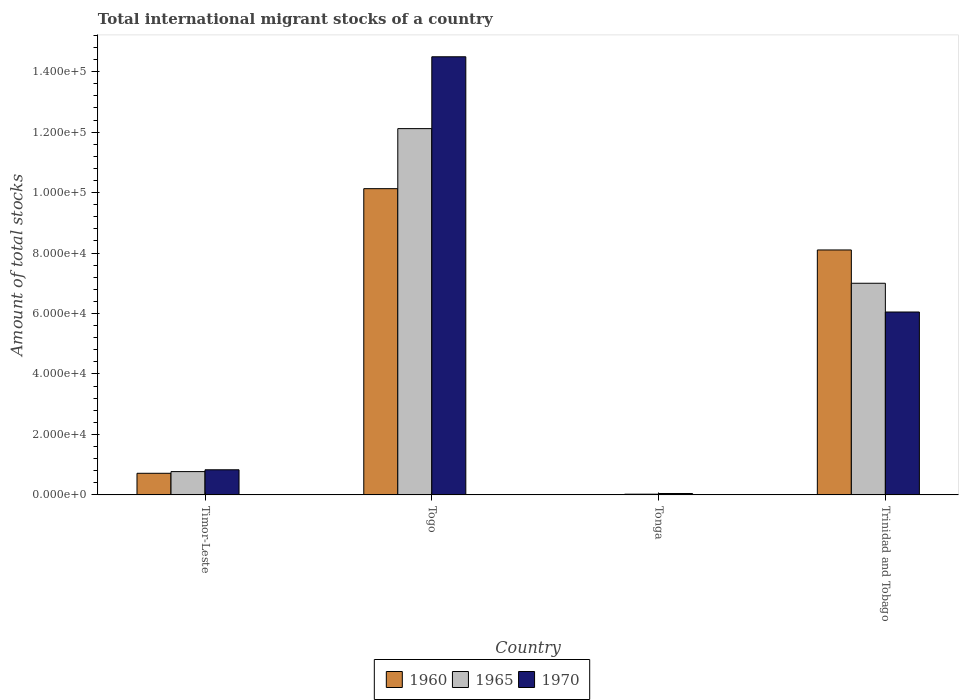How many groups of bars are there?
Provide a succinct answer. 4. How many bars are there on the 3rd tick from the right?
Give a very brief answer. 3. What is the label of the 1st group of bars from the left?
Give a very brief answer. Timor-Leste. In how many cases, is the number of bars for a given country not equal to the number of legend labels?
Provide a short and direct response. 0. What is the amount of total stocks in in 1960 in Timor-Leste?
Offer a very short reply. 7148. Across all countries, what is the maximum amount of total stocks in in 1960?
Offer a very short reply. 1.01e+05. Across all countries, what is the minimum amount of total stocks in in 1965?
Your answer should be very brief. 236. In which country was the amount of total stocks in in 1965 maximum?
Offer a terse response. Togo. In which country was the amount of total stocks in in 1970 minimum?
Keep it short and to the point. Tonga. What is the total amount of total stocks in in 1970 in the graph?
Offer a terse response. 2.14e+05. What is the difference between the amount of total stocks in in 1960 in Timor-Leste and that in Trinidad and Tobago?
Offer a terse response. -7.39e+04. What is the difference between the amount of total stocks in in 1960 in Trinidad and Tobago and the amount of total stocks in in 1970 in Timor-Leste?
Your answer should be compact. 7.27e+04. What is the average amount of total stocks in in 1965 per country?
Ensure brevity in your answer.  4.98e+04. What is the difference between the amount of total stocks in of/in 1960 and amount of total stocks in of/in 1970 in Timor-Leste?
Ensure brevity in your answer.  -1158. In how many countries, is the amount of total stocks in in 1960 greater than 72000?
Make the answer very short. 2. What is the ratio of the amount of total stocks in in 1965 in Togo to that in Trinidad and Tobago?
Provide a succinct answer. 1.73. Is the amount of total stocks in in 1965 in Togo less than that in Trinidad and Tobago?
Offer a very short reply. No. Is the difference between the amount of total stocks in in 1960 in Togo and Trinidad and Tobago greater than the difference between the amount of total stocks in in 1970 in Togo and Trinidad and Tobago?
Offer a very short reply. No. What is the difference between the highest and the second highest amount of total stocks in in 1970?
Give a very brief answer. -1.37e+05. What is the difference between the highest and the lowest amount of total stocks in in 1970?
Offer a very short reply. 1.44e+05. What does the 1st bar from the left in Tonga represents?
Your answer should be very brief. 1960. What does the 2nd bar from the right in Trinidad and Tobago represents?
Your answer should be very brief. 1965. Is it the case that in every country, the sum of the amount of total stocks in in 1970 and amount of total stocks in in 1960 is greater than the amount of total stocks in in 1965?
Your response must be concise. Yes. What is the difference between two consecutive major ticks on the Y-axis?
Give a very brief answer. 2.00e+04. Does the graph contain any zero values?
Offer a very short reply. No. How many legend labels are there?
Provide a succinct answer. 3. What is the title of the graph?
Provide a short and direct response. Total international migrant stocks of a country. Does "2013" appear as one of the legend labels in the graph?
Ensure brevity in your answer.  No. What is the label or title of the X-axis?
Provide a succinct answer. Country. What is the label or title of the Y-axis?
Ensure brevity in your answer.  Amount of total stocks. What is the Amount of total stocks in 1960 in Timor-Leste?
Your response must be concise. 7148. What is the Amount of total stocks of 1965 in Timor-Leste?
Provide a short and direct response. 7705. What is the Amount of total stocks of 1970 in Timor-Leste?
Offer a terse response. 8306. What is the Amount of total stocks in 1960 in Togo?
Your answer should be very brief. 1.01e+05. What is the Amount of total stocks in 1965 in Togo?
Your answer should be compact. 1.21e+05. What is the Amount of total stocks of 1970 in Togo?
Offer a terse response. 1.45e+05. What is the Amount of total stocks in 1960 in Tonga?
Keep it short and to the point. 121. What is the Amount of total stocks of 1965 in Tonga?
Provide a succinct answer. 236. What is the Amount of total stocks in 1970 in Tonga?
Your answer should be very brief. 460. What is the Amount of total stocks of 1960 in Trinidad and Tobago?
Give a very brief answer. 8.10e+04. What is the Amount of total stocks in 1965 in Trinidad and Tobago?
Make the answer very short. 7.00e+04. What is the Amount of total stocks in 1970 in Trinidad and Tobago?
Offer a very short reply. 6.05e+04. Across all countries, what is the maximum Amount of total stocks in 1960?
Keep it short and to the point. 1.01e+05. Across all countries, what is the maximum Amount of total stocks of 1965?
Your response must be concise. 1.21e+05. Across all countries, what is the maximum Amount of total stocks of 1970?
Provide a succinct answer. 1.45e+05. Across all countries, what is the minimum Amount of total stocks in 1960?
Make the answer very short. 121. Across all countries, what is the minimum Amount of total stocks of 1965?
Keep it short and to the point. 236. Across all countries, what is the minimum Amount of total stocks in 1970?
Make the answer very short. 460. What is the total Amount of total stocks in 1960 in the graph?
Keep it short and to the point. 1.90e+05. What is the total Amount of total stocks in 1965 in the graph?
Your response must be concise. 1.99e+05. What is the total Amount of total stocks of 1970 in the graph?
Your answer should be compact. 2.14e+05. What is the difference between the Amount of total stocks of 1960 in Timor-Leste and that in Togo?
Your answer should be very brief. -9.41e+04. What is the difference between the Amount of total stocks in 1965 in Timor-Leste and that in Togo?
Provide a succinct answer. -1.13e+05. What is the difference between the Amount of total stocks in 1970 in Timor-Leste and that in Togo?
Keep it short and to the point. -1.37e+05. What is the difference between the Amount of total stocks of 1960 in Timor-Leste and that in Tonga?
Offer a terse response. 7027. What is the difference between the Amount of total stocks in 1965 in Timor-Leste and that in Tonga?
Make the answer very short. 7469. What is the difference between the Amount of total stocks in 1970 in Timor-Leste and that in Tonga?
Your answer should be compact. 7846. What is the difference between the Amount of total stocks in 1960 in Timor-Leste and that in Trinidad and Tobago?
Your answer should be very brief. -7.39e+04. What is the difference between the Amount of total stocks of 1965 in Timor-Leste and that in Trinidad and Tobago?
Ensure brevity in your answer.  -6.23e+04. What is the difference between the Amount of total stocks in 1970 in Timor-Leste and that in Trinidad and Tobago?
Ensure brevity in your answer.  -5.22e+04. What is the difference between the Amount of total stocks in 1960 in Togo and that in Tonga?
Provide a short and direct response. 1.01e+05. What is the difference between the Amount of total stocks of 1965 in Togo and that in Tonga?
Your answer should be very brief. 1.21e+05. What is the difference between the Amount of total stocks in 1970 in Togo and that in Tonga?
Make the answer very short. 1.44e+05. What is the difference between the Amount of total stocks in 1960 in Togo and that in Trinidad and Tobago?
Provide a short and direct response. 2.03e+04. What is the difference between the Amount of total stocks of 1965 in Togo and that in Trinidad and Tobago?
Ensure brevity in your answer.  5.12e+04. What is the difference between the Amount of total stocks in 1970 in Togo and that in Trinidad and Tobago?
Ensure brevity in your answer.  8.44e+04. What is the difference between the Amount of total stocks in 1960 in Tonga and that in Trinidad and Tobago?
Give a very brief answer. -8.09e+04. What is the difference between the Amount of total stocks in 1965 in Tonga and that in Trinidad and Tobago?
Your response must be concise. -6.98e+04. What is the difference between the Amount of total stocks of 1970 in Tonga and that in Trinidad and Tobago?
Your response must be concise. -6.00e+04. What is the difference between the Amount of total stocks of 1960 in Timor-Leste and the Amount of total stocks of 1965 in Togo?
Your answer should be compact. -1.14e+05. What is the difference between the Amount of total stocks of 1960 in Timor-Leste and the Amount of total stocks of 1970 in Togo?
Make the answer very short. -1.38e+05. What is the difference between the Amount of total stocks of 1965 in Timor-Leste and the Amount of total stocks of 1970 in Togo?
Give a very brief answer. -1.37e+05. What is the difference between the Amount of total stocks of 1960 in Timor-Leste and the Amount of total stocks of 1965 in Tonga?
Provide a short and direct response. 6912. What is the difference between the Amount of total stocks in 1960 in Timor-Leste and the Amount of total stocks in 1970 in Tonga?
Your response must be concise. 6688. What is the difference between the Amount of total stocks of 1965 in Timor-Leste and the Amount of total stocks of 1970 in Tonga?
Give a very brief answer. 7245. What is the difference between the Amount of total stocks in 1960 in Timor-Leste and the Amount of total stocks in 1965 in Trinidad and Tobago?
Provide a short and direct response. -6.29e+04. What is the difference between the Amount of total stocks of 1960 in Timor-Leste and the Amount of total stocks of 1970 in Trinidad and Tobago?
Offer a terse response. -5.33e+04. What is the difference between the Amount of total stocks in 1965 in Timor-Leste and the Amount of total stocks in 1970 in Trinidad and Tobago?
Make the answer very short. -5.28e+04. What is the difference between the Amount of total stocks in 1960 in Togo and the Amount of total stocks in 1965 in Tonga?
Ensure brevity in your answer.  1.01e+05. What is the difference between the Amount of total stocks in 1960 in Togo and the Amount of total stocks in 1970 in Tonga?
Your response must be concise. 1.01e+05. What is the difference between the Amount of total stocks in 1965 in Togo and the Amount of total stocks in 1970 in Tonga?
Provide a succinct answer. 1.21e+05. What is the difference between the Amount of total stocks of 1960 in Togo and the Amount of total stocks of 1965 in Trinidad and Tobago?
Provide a short and direct response. 3.13e+04. What is the difference between the Amount of total stocks in 1960 in Togo and the Amount of total stocks in 1970 in Trinidad and Tobago?
Provide a short and direct response. 4.08e+04. What is the difference between the Amount of total stocks in 1965 in Togo and the Amount of total stocks in 1970 in Trinidad and Tobago?
Make the answer very short. 6.07e+04. What is the difference between the Amount of total stocks in 1960 in Tonga and the Amount of total stocks in 1965 in Trinidad and Tobago?
Your answer should be very brief. -6.99e+04. What is the difference between the Amount of total stocks in 1960 in Tonga and the Amount of total stocks in 1970 in Trinidad and Tobago?
Provide a short and direct response. -6.04e+04. What is the difference between the Amount of total stocks in 1965 in Tonga and the Amount of total stocks in 1970 in Trinidad and Tobago?
Provide a short and direct response. -6.03e+04. What is the average Amount of total stocks in 1960 per country?
Provide a short and direct response. 4.74e+04. What is the average Amount of total stocks of 1965 per country?
Your response must be concise. 4.98e+04. What is the average Amount of total stocks in 1970 per country?
Ensure brevity in your answer.  5.35e+04. What is the difference between the Amount of total stocks in 1960 and Amount of total stocks in 1965 in Timor-Leste?
Offer a terse response. -557. What is the difference between the Amount of total stocks in 1960 and Amount of total stocks in 1970 in Timor-Leste?
Offer a terse response. -1158. What is the difference between the Amount of total stocks of 1965 and Amount of total stocks of 1970 in Timor-Leste?
Keep it short and to the point. -601. What is the difference between the Amount of total stocks of 1960 and Amount of total stocks of 1965 in Togo?
Provide a succinct answer. -1.99e+04. What is the difference between the Amount of total stocks in 1960 and Amount of total stocks in 1970 in Togo?
Offer a very short reply. -4.36e+04. What is the difference between the Amount of total stocks in 1965 and Amount of total stocks in 1970 in Togo?
Give a very brief answer. -2.38e+04. What is the difference between the Amount of total stocks in 1960 and Amount of total stocks in 1965 in Tonga?
Offer a terse response. -115. What is the difference between the Amount of total stocks in 1960 and Amount of total stocks in 1970 in Tonga?
Your answer should be compact. -339. What is the difference between the Amount of total stocks of 1965 and Amount of total stocks of 1970 in Tonga?
Your answer should be compact. -224. What is the difference between the Amount of total stocks in 1960 and Amount of total stocks in 1965 in Trinidad and Tobago?
Offer a very short reply. 1.10e+04. What is the difference between the Amount of total stocks of 1960 and Amount of total stocks of 1970 in Trinidad and Tobago?
Keep it short and to the point. 2.05e+04. What is the difference between the Amount of total stocks of 1965 and Amount of total stocks of 1970 in Trinidad and Tobago?
Your response must be concise. 9509. What is the ratio of the Amount of total stocks in 1960 in Timor-Leste to that in Togo?
Your answer should be compact. 0.07. What is the ratio of the Amount of total stocks in 1965 in Timor-Leste to that in Togo?
Provide a succinct answer. 0.06. What is the ratio of the Amount of total stocks of 1970 in Timor-Leste to that in Togo?
Your answer should be very brief. 0.06. What is the ratio of the Amount of total stocks of 1960 in Timor-Leste to that in Tonga?
Your response must be concise. 59.07. What is the ratio of the Amount of total stocks in 1965 in Timor-Leste to that in Tonga?
Make the answer very short. 32.65. What is the ratio of the Amount of total stocks in 1970 in Timor-Leste to that in Tonga?
Keep it short and to the point. 18.06. What is the ratio of the Amount of total stocks in 1960 in Timor-Leste to that in Trinidad and Tobago?
Your answer should be compact. 0.09. What is the ratio of the Amount of total stocks of 1965 in Timor-Leste to that in Trinidad and Tobago?
Your answer should be very brief. 0.11. What is the ratio of the Amount of total stocks of 1970 in Timor-Leste to that in Trinidad and Tobago?
Make the answer very short. 0.14. What is the ratio of the Amount of total stocks of 1960 in Togo to that in Tonga?
Make the answer very short. 837.12. What is the ratio of the Amount of total stocks of 1965 in Togo to that in Tonga?
Your answer should be compact. 513.37. What is the ratio of the Amount of total stocks in 1970 in Togo to that in Tonga?
Offer a terse response. 315.03. What is the ratio of the Amount of total stocks in 1960 in Togo to that in Trinidad and Tobago?
Make the answer very short. 1.25. What is the ratio of the Amount of total stocks of 1965 in Togo to that in Trinidad and Tobago?
Your response must be concise. 1.73. What is the ratio of the Amount of total stocks of 1970 in Togo to that in Trinidad and Tobago?
Your answer should be very brief. 2.4. What is the ratio of the Amount of total stocks of 1960 in Tonga to that in Trinidad and Tobago?
Make the answer very short. 0. What is the ratio of the Amount of total stocks in 1965 in Tonga to that in Trinidad and Tobago?
Keep it short and to the point. 0. What is the ratio of the Amount of total stocks in 1970 in Tonga to that in Trinidad and Tobago?
Provide a succinct answer. 0.01. What is the difference between the highest and the second highest Amount of total stocks in 1960?
Offer a terse response. 2.03e+04. What is the difference between the highest and the second highest Amount of total stocks of 1965?
Offer a terse response. 5.12e+04. What is the difference between the highest and the second highest Amount of total stocks in 1970?
Ensure brevity in your answer.  8.44e+04. What is the difference between the highest and the lowest Amount of total stocks in 1960?
Your answer should be compact. 1.01e+05. What is the difference between the highest and the lowest Amount of total stocks in 1965?
Give a very brief answer. 1.21e+05. What is the difference between the highest and the lowest Amount of total stocks in 1970?
Provide a succinct answer. 1.44e+05. 